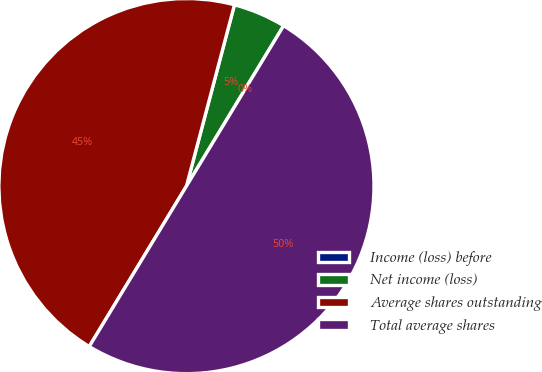Convert chart to OTSL. <chart><loc_0><loc_0><loc_500><loc_500><pie_chart><fcel>Income (loss) before<fcel>Net income (loss)<fcel>Average shares outstanding<fcel>Total average shares<nl><fcel>0.0%<fcel>4.55%<fcel>45.45%<fcel>50.0%<nl></chart> 